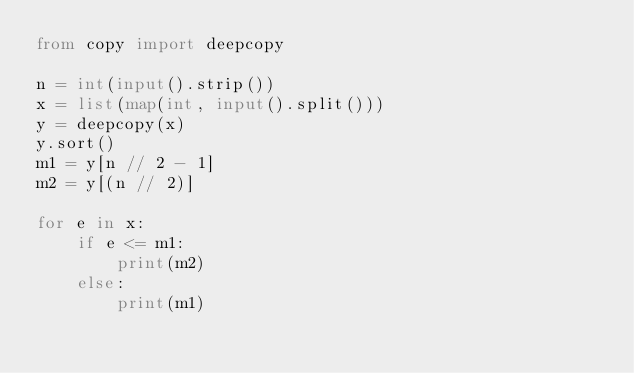<code> <loc_0><loc_0><loc_500><loc_500><_Python_>from copy import deepcopy

n = int(input().strip())
x = list(map(int, input().split()))
y = deepcopy(x)
y.sort()
m1 = y[n // 2 - 1]
m2 = y[(n // 2)]

for e in x:
    if e <= m1:
        print(m2)
    else:
        print(m1)
</code> 